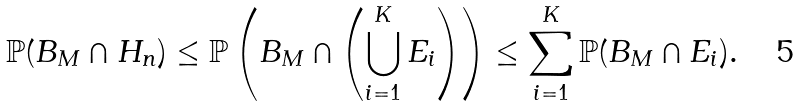<formula> <loc_0><loc_0><loc_500><loc_500>\mathbb { P } ( B _ { M } \cap H _ { n } ) & \leq \mathbb { P } \left ( B _ { M } \cap \left ( \bigcup _ { i = 1 } ^ { K } E _ { i } \right ) \right ) \leq \sum _ { i = 1 } ^ { K } \mathbb { P } ( B _ { M } \cap E _ { i } ) .</formula> 